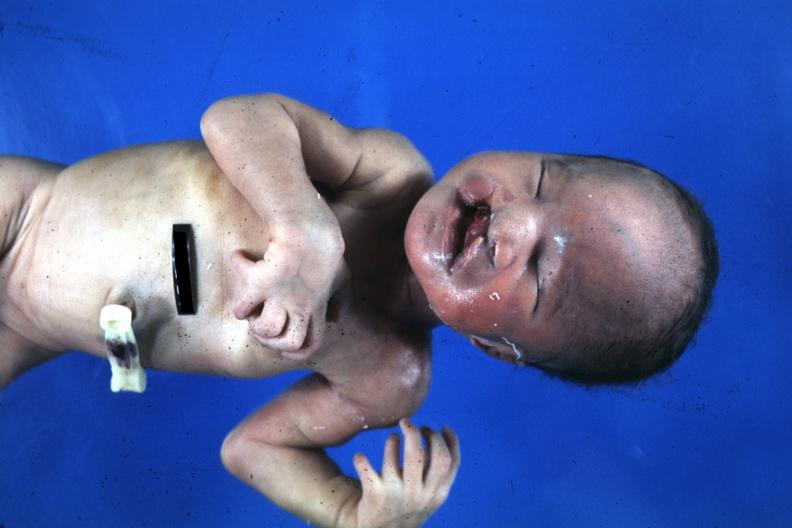what is present?
Answer the question using a single word or phrase. Bilateral cleft palate 